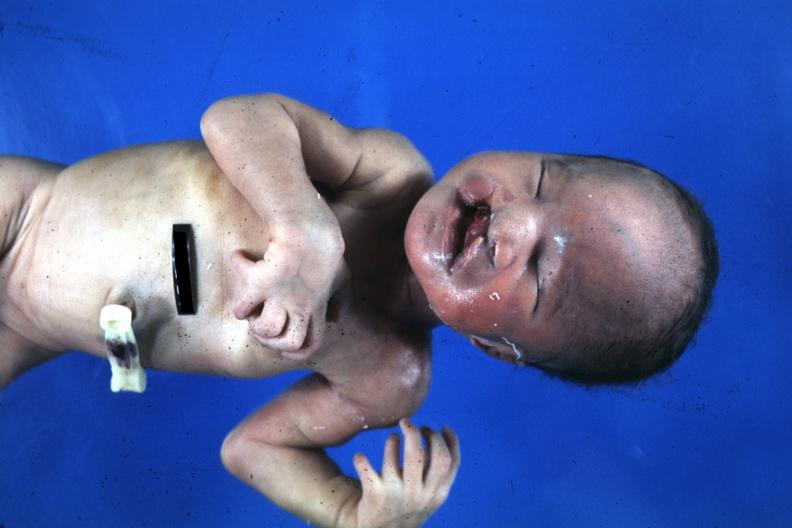what is present?
Answer the question using a single word or phrase. Bilateral cleft palate 